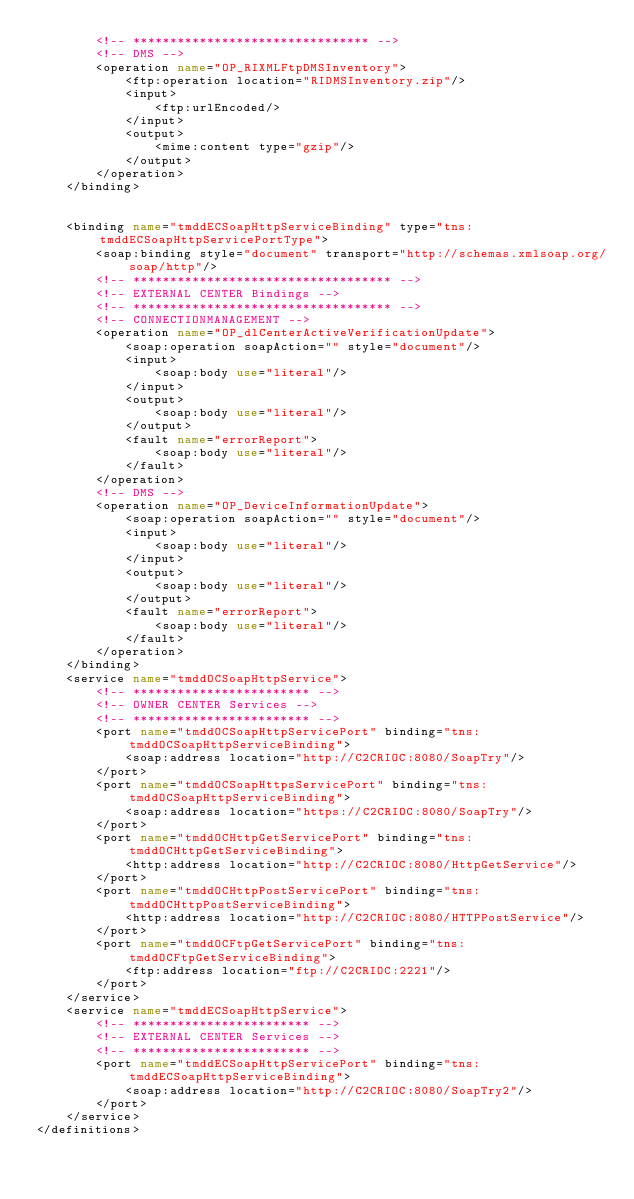<code> <loc_0><loc_0><loc_500><loc_500><_XML_>		<!-- ******************************** -->
		<!-- DMS -->
		<operation name="OP_RIXMLFtpDMSInventory">
			<ftp:operation location="RIDMSInventory.zip"/>
			<input>
				<ftp:urlEncoded/>
			</input>
			<output>
				<mime:content type="gzip"/>
			</output>
		</operation>
	</binding>


	<binding name="tmddECSoapHttpServiceBinding" type="tns:tmddECSoapHttpServicePortType">
		<soap:binding style="document" transport="http://schemas.xmlsoap.org/soap/http"/>
		<!-- *********************************** -->
		<!-- EXTERNAL CENTER Bindings -->
		<!-- *********************************** -->
		<!-- CONNECTIONMANAGEMENT -->
		<operation name="OP_dlCenterActiveVerificationUpdate">
			<soap:operation soapAction="" style="document"/>
			<input>
				<soap:body use="literal"/>
			</input>
			<output>
				<soap:body use="literal"/>
			</output>
			<fault name="errorReport">
				<soap:body use="literal"/>
			</fault>
		</operation>
		<!-- DMS -->
		<operation name="OP_DeviceInformationUpdate">
			<soap:operation soapAction="" style="document"/>
			<input>
				<soap:body use="literal"/>
			</input>
			<output>
				<soap:body use="literal"/>
			</output>
			<fault name="errorReport">
				<soap:body use="literal"/>
			</fault>
		</operation>
	</binding>
	<service name="tmddOCSoapHttpService">
		<!-- ************************ -->
		<!-- OWNER CENTER Services -->
		<!-- ************************ -->
		<port name="tmddOCSoapHttpServicePort" binding="tns:tmddOCSoapHttpServiceBinding">
			<soap:address location="http://C2CRIOC:8080/SoapTry"/>
		</port>
		<port name="tmddOCSoapHttpsServicePort" binding="tns:tmddOCSoapHttpServiceBinding">
			<soap:address location="https://C2CRIOC:8080/SoapTry"/>
		</port>
		<port name="tmddOCHttpGetServicePort" binding="tns:tmddOCHttpGetServiceBinding">
			<http:address location="http://C2CRIOC:8080/HttpGetService"/>
		</port>
		<port name="tmddOCHttpPostServicePort" binding="tns:tmddOCHttpPostServiceBinding">
			<http:address location="http://C2CRIOC:8080/HTTPPostService"/>
		</port>
		<port name="tmddOCFtpGetServicePort" binding="tns:tmddOCFtpGetServiceBinding">
			<ftp:address location="ftp://C2CRIOC:2221"/>
		</port>
	</service>
	<service name="tmddECSoapHttpService">
		<!-- ************************ -->
		<!-- EXTERNAL CENTER Services -->
		<!-- ************************ -->
		<port name="tmddECSoapHttpServicePort" binding="tns:tmddECSoapHttpServiceBinding">
			<soap:address location="http://C2CRIOC:8080/SoapTry2"/>
		</port>
	</service>
</definitions>
</code> 